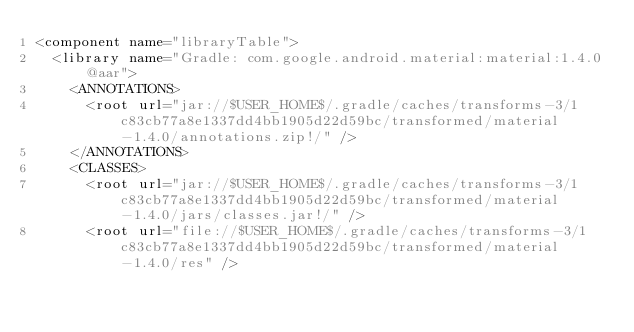Convert code to text. <code><loc_0><loc_0><loc_500><loc_500><_XML_><component name="libraryTable">
  <library name="Gradle: com.google.android.material:material:1.4.0@aar">
    <ANNOTATIONS>
      <root url="jar://$USER_HOME$/.gradle/caches/transforms-3/1c83cb77a8e1337dd4bb1905d22d59bc/transformed/material-1.4.0/annotations.zip!/" />
    </ANNOTATIONS>
    <CLASSES>
      <root url="jar://$USER_HOME$/.gradle/caches/transforms-3/1c83cb77a8e1337dd4bb1905d22d59bc/transformed/material-1.4.0/jars/classes.jar!/" />
      <root url="file://$USER_HOME$/.gradle/caches/transforms-3/1c83cb77a8e1337dd4bb1905d22d59bc/transformed/material-1.4.0/res" /></code> 